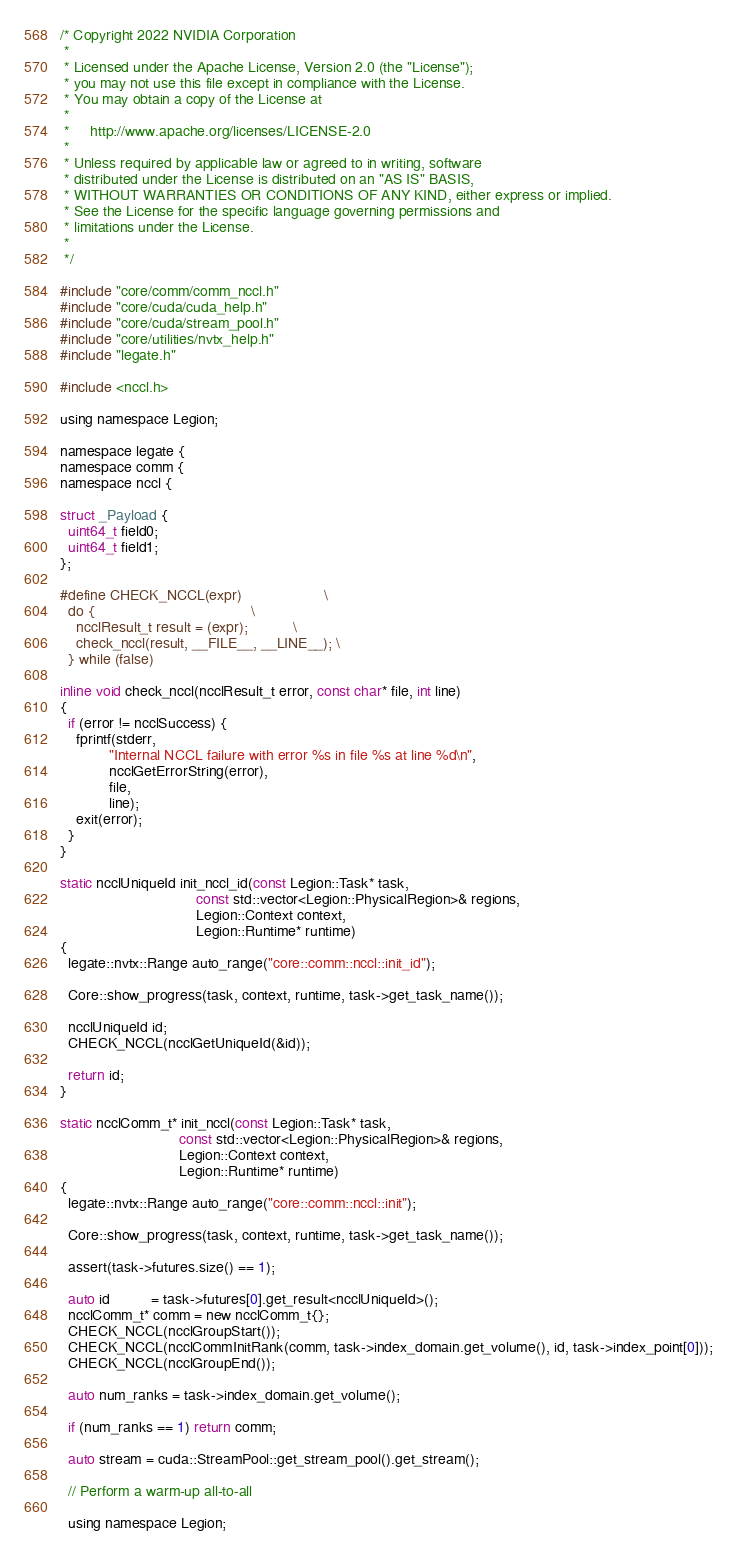Convert code to text. <code><loc_0><loc_0><loc_500><loc_500><_Cuda_>/* Copyright 2022 NVIDIA Corporation
 *
 * Licensed under the Apache License, Version 2.0 (the "License");
 * you may not use this file except in compliance with the License.
 * You may obtain a copy of the License at
 *
 *     http://www.apache.org/licenses/LICENSE-2.0
 *
 * Unless required by applicable law or agreed to in writing, software
 * distributed under the License is distributed on an "AS IS" BASIS,
 * WITHOUT WARRANTIES OR CONDITIONS OF ANY KIND, either express or implied.
 * See the License for the specific language governing permissions and
 * limitations under the License.
 *
 */

#include "core/comm/comm_nccl.h"
#include "core/cuda/cuda_help.h"
#include "core/cuda/stream_pool.h"
#include "core/utilities/nvtx_help.h"
#include "legate.h"

#include <nccl.h>

using namespace Legion;

namespace legate {
namespace comm {
namespace nccl {

struct _Payload {
  uint64_t field0;
  uint64_t field1;
};

#define CHECK_NCCL(expr)                    \
  do {                                      \
    ncclResult_t result = (expr);           \
    check_nccl(result, __FILE__, __LINE__); \
  } while (false)

inline void check_nccl(ncclResult_t error, const char* file, int line)
{
  if (error != ncclSuccess) {
    fprintf(stderr,
            "Internal NCCL failure with error %s in file %s at line %d\n",
            ncclGetErrorString(error),
            file,
            line);
    exit(error);
  }
}

static ncclUniqueId init_nccl_id(const Legion::Task* task,
                                 const std::vector<Legion::PhysicalRegion>& regions,
                                 Legion::Context context,
                                 Legion::Runtime* runtime)
{
  legate::nvtx::Range auto_range("core::comm::nccl::init_id");

  Core::show_progress(task, context, runtime, task->get_task_name());

  ncclUniqueId id;
  CHECK_NCCL(ncclGetUniqueId(&id));

  return id;
}

static ncclComm_t* init_nccl(const Legion::Task* task,
                             const std::vector<Legion::PhysicalRegion>& regions,
                             Legion::Context context,
                             Legion::Runtime* runtime)
{
  legate::nvtx::Range auto_range("core::comm::nccl::init");

  Core::show_progress(task, context, runtime, task->get_task_name());

  assert(task->futures.size() == 1);

  auto id          = task->futures[0].get_result<ncclUniqueId>();
  ncclComm_t* comm = new ncclComm_t{};
  CHECK_NCCL(ncclGroupStart());
  CHECK_NCCL(ncclCommInitRank(comm, task->index_domain.get_volume(), id, task->index_point[0]));
  CHECK_NCCL(ncclGroupEnd());

  auto num_ranks = task->index_domain.get_volume();

  if (num_ranks == 1) return comm;

  auto stream = cuda::StreamPool::get_stream_pool().get_stream();

  // Perform a warm-up all-to-all

  using namespace Legion;
</code> 